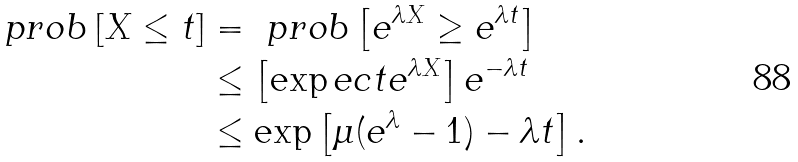Convert formula to latex. <formula><loc_0><loc_0><loc_500><loc_500>\ p r o b \left [ X \leq t \right ] & = \ p r o b \left [ e ^ { \lambda X } \geq e ^ { \lambda t } \right ] \\ & \leq \left [ \exp e c t e ^ { \lambda X } \right ] e ^ { - \lambda t } \\ & \leq \exp \left [ \mu ( e ^ { \lambda } - 1 ) - \lambda t \right ] .</formula> 